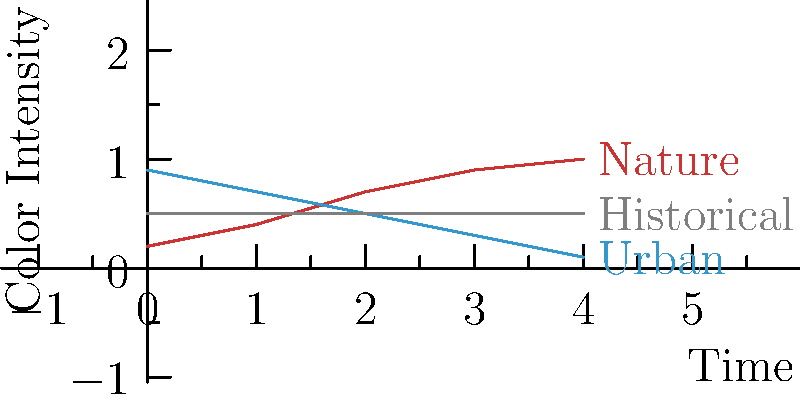Analyze the color grading trends depicted in the graph for nature, urban, and historical documentaries. Which genre typically maintains the most consistent color palette throughout the film, and what might be the artistic rationale behind this approach? To answer this question, let's analyze the color grading trends for each documentary genre:

1. Nature documentaries (red line):
   - Shows an upward trend in color intensity over time
   - Starts with low intensity and gradually increases to high intensity
   - This could represent a shift from muted colors to vibrant, saturated hues

2. Urban documentaries (blue line):
   - Displays a downward trend in color intensity over time
   - Begins with high intensity and decreases to low intensity
   - This might indicate a transition from bright, energetic colors to more subdued tones

3. Historical documentaries (gray line):
   - Maintains a constant color intensity throughout the timeline
   - The line is flat, suggesting no significant changes in color grading
   - This approach keeps a consistent color palette from start to finish

The genre that maintains the most consistent color palette is historical documentaries. The artistic rationale behind this approach could be:

1. Authenticity: Maintaining a consistent, often muted or desaturated color palette can evoke a sense of the past and historical accuracy.

2. Mood preservation: A stable color grade helps maintain a consistent emotional tone throughout the documentary, which is often crucial in historical narratives.

3. Focus on content: By avoiding dramatic color shifts, the filmmaker ensures that the audience's attention remains on the historical information and archival footage rather than visual aesthetics.

4. Period-appropriate aesthetics: The consistent color grading may mimic the look of old photographs or film footage, reinforcing the historical context.

5. Avoiding anachronisms: A stable color palette reduces the risk of introducing modern-looking color treatments that might feel out of place in a historical context.

This approach in historical documentaries contrasts with the dynamic color grading seen in nature and urban documentaries, where changing color intensities might be used to reflect environmental shifts or narrative progression.
Answer: Historical documentaries; maintains authenticity, focuses on content, and evokes period-appropriate aesthetics. 